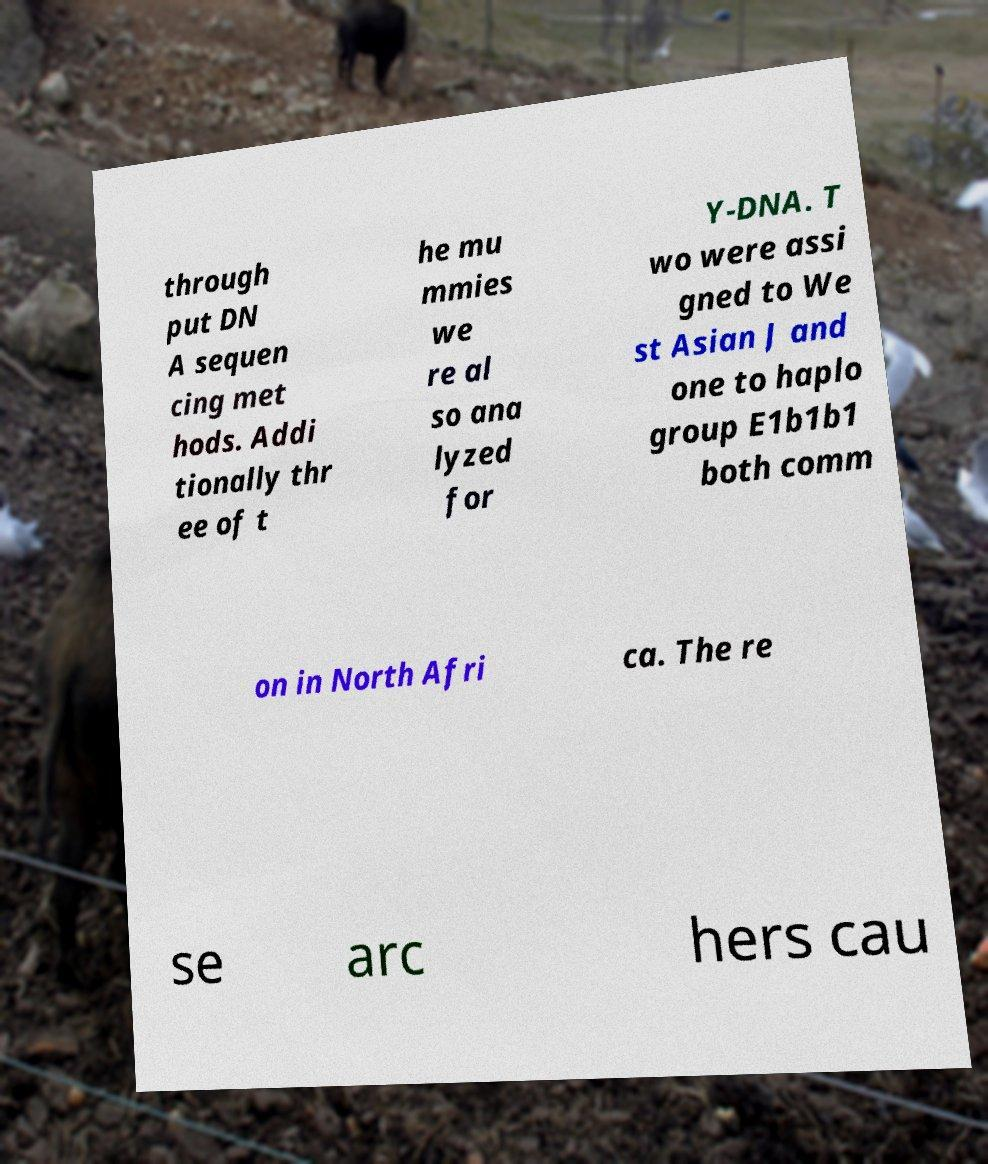Please read and relay the text visible in this image. What does it say? through put DN A sequen cing met hods. Addi tionally thr ee of t he mu mmies we re al so ana lyzed for Y-DNA. T wo were assi gned to We st Asian J and one to haplo group E1b1b1 both comm on in North Afri ca. The re se arc hers cau 